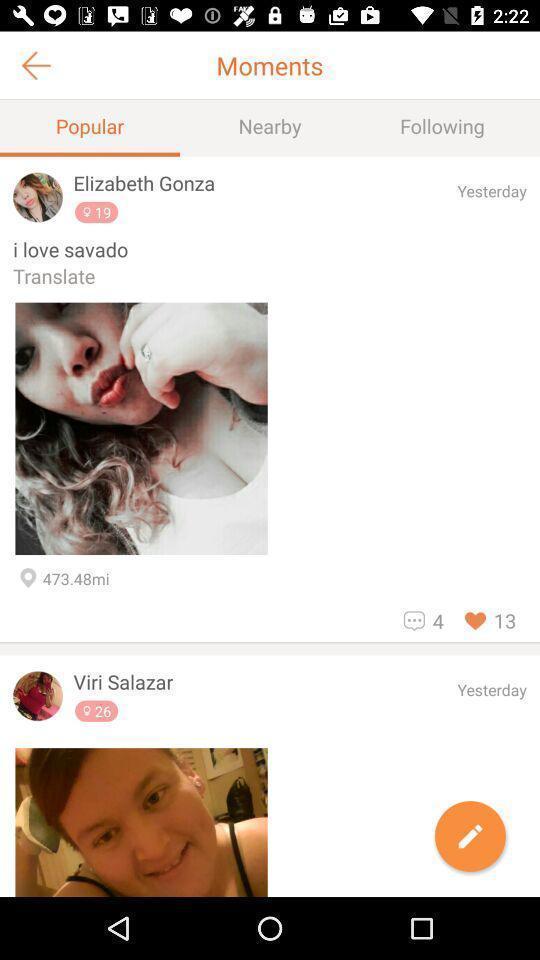Explain what's happening in this screen capture. Page showing popular moments in the social app. 